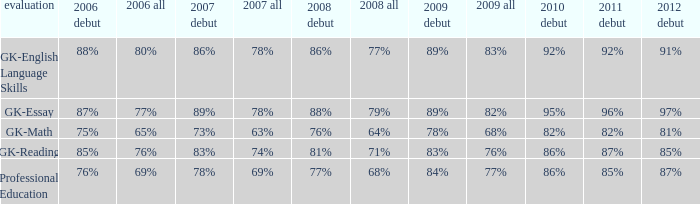What is the rate for all in 2008 when all in 2007 was 69%? 68%. 